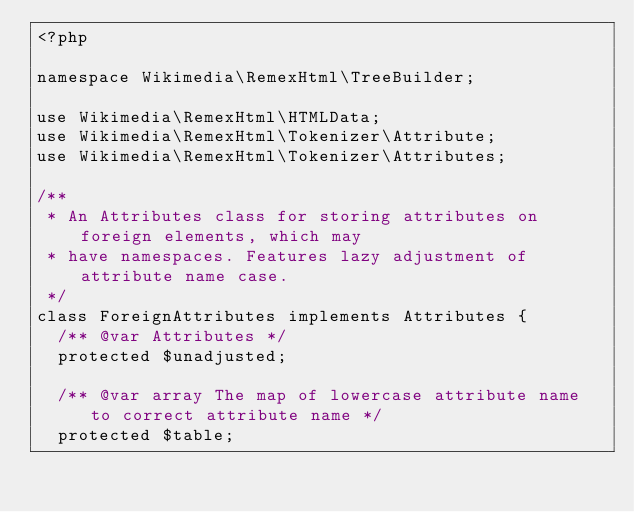<code> <loc_0><loc_0><loc_500><loc_500><_PHP_><?php

namespace Wikimedia\RemexHtml\TreeBuilder;

use Wikimedia\RemexHtml\HTMLData;
use Wikimedia\RemexHtml\Tokenizer\Attribute;
use Wikimedia\RemexHtml\Tokenizer\Attributes;

/**
 * An Attributes class for storing attributes on foreign elements, which may
 * have namespaces. Features lazy adjustment of attribute name case.
 */
class ForeignAttributes implements Attributes {
	/** @var Attributes */
	protected $unadjusted;

	/** @var array The map of lowercase attribute name to correct attribute name */
	protected $table;
</code> 